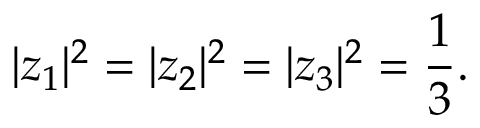<formula> <loc_0><loc_0><loc_500><loc_500>| z _ { 1 } | ^ { 2 } = | z _ { 2 } | ^ { 2 } = | z _ { 3 } | ^ { 2 } = \frac { 1 } { 3 } .</formula> 